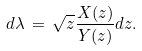<formula> <loc_0><loc_0><loc_500><loc_500>d \lambda \, = \, \sqrt { z } \frac { X ( z ) } { Y ( z ) } d z .</formula> 